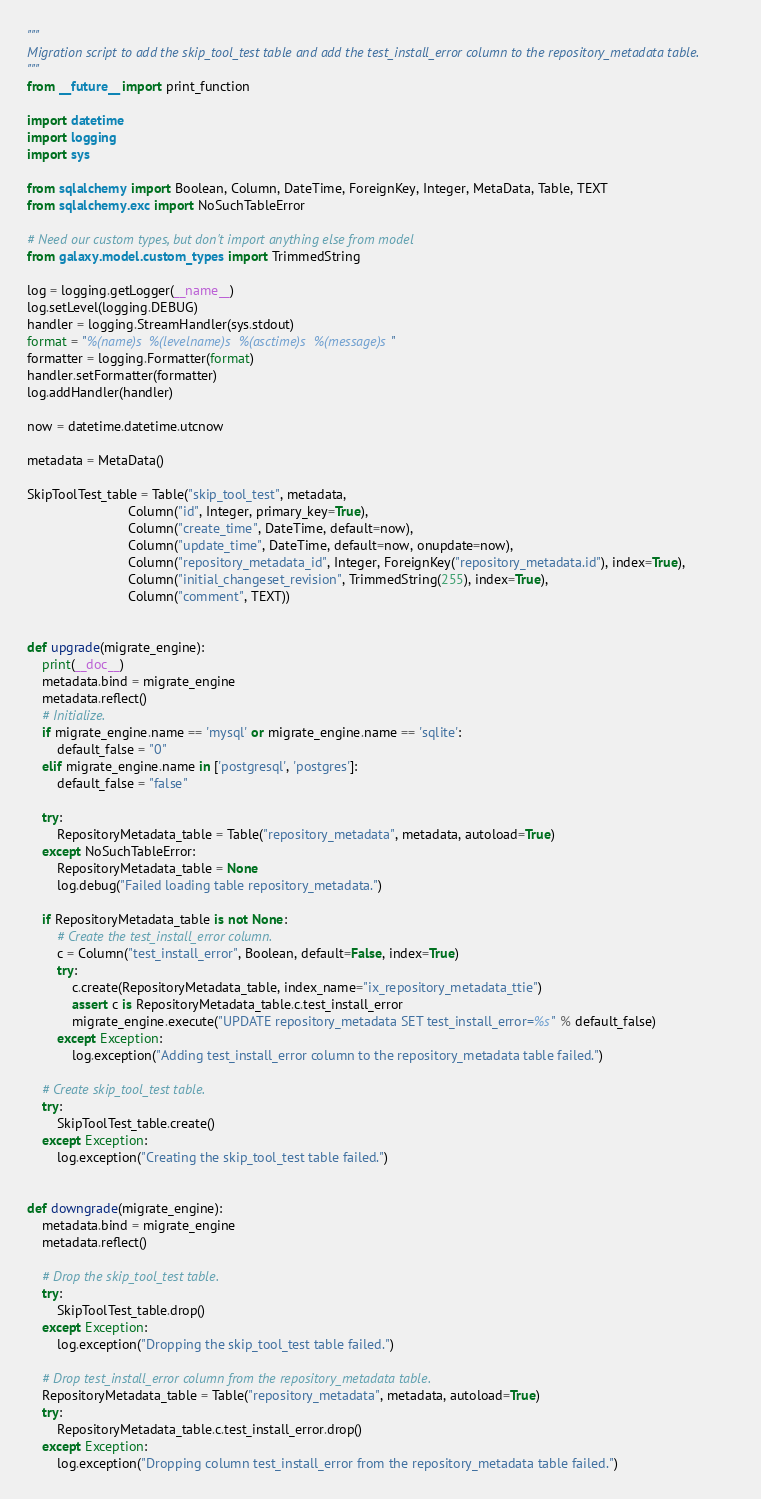<code> <loc_0><loc_0><loc_500><loc_500><_Python_>"""
Migration script to add the skip_tool_test table and add the test_install_error column to the repository_metadata table.
"""
from __future__ import print_function

import datetime
import logging
import sys

from sqlalchemy import Boolean, Column, DateTime, ForeignKey, Integer, MetaData, Table, TEXT
from sqlalchemy.exc import NoSuchTableError

# Need our custom types, but don't import anything else from model
from galaxy.model.custom_types import TrimmedString

log = logging.getLogger(__name__)
log.setLevel(logging.DEBUG)
handler = logging.StreamHandler(sys.stdout)
format = "%(name)s %(levelname)s %(asctime)s %(message)s"
formatter = logging.Formatter(format)
handler.setFormatter(formatter)
log.addHandler(handler)

now = datetime.datetime.utcnow

metadata = MetaData()

SkipToolTest_table = Table("skip_tool_test", metadata,
                           Column("id", Integer, primary_key=True),
                           Column("create_time", DateTime, default=now),
                           Column("update_time", DateTime, default=now, onupdate=now),
                           Column("repository_metadata_id", Integer, ForeignKey("repository_metadata.id"), index=True),
                           Column("initial_changeset_revision", TrimmedString(255), index=True),
                           Column("comment", TEXT))


def upgrade(migrate_engine):
    print(__doc__)
    metadata.bind = migrate_engine
    metadata.reflect()
    # Initialize.
    if migrate_engine.name == 'mysql' or migrate_engine.name == 'sqlite':
        default_false = "0"
    elif migrate_engine.name in ['postgresql', 'postgres']:
        default_false = "false"

    try:
        RepositoryMetadata_table = Table("repository_metadata", metadata, autoload=True)
    except NoSuchTableError:
        RepositoryMetadata_table = None
        log.debug("Failed loading table repository_metadata.")

    if RepositoryMetadata_table is not None:
        # Create the test_install_error column.
        c = Column("test_install_error", Boolean, default=False, index=True)
        try:
            c.create(RepositoryMetadata_table, index_name="ix_repository_metadata_ttie")
            assert c is RepositoryMetadata_table.c.test_install_error
            migrate_engine.execute("UPDATE repository_metadata SET test_install_error=%s" % default_false)
        except Exception:
            log.exception("Adding test_install_error column to the repository_metadata table failed.")

    # Create skip_tool_test table.
    try:
        SkipToolTest_table.create()
    except Exception:
        log.exception("Creating the skip_tool_test table failed.")


def downgrade(migrate_engine):
    metadata.bind = migrate_engine
    metadata.reflect()

    # Drop the skip_tool_test table.
    try:
        SkipToolTest_table.drop()
    except Exception:
        log.exception("Dropping the skip_tool_test table failed.")

    # Drop test_install_error column from the repository_metadata table.
    RepositoryMetadata_table = Table("repository_metadata", metadata, autoload=True)
    try:
        RepositoryMetadata_table.c.test_install_error.drop()
    except Exception:
        log.exception("Dropping column test_install_error from the repository_metadata table failed.")
</code> 